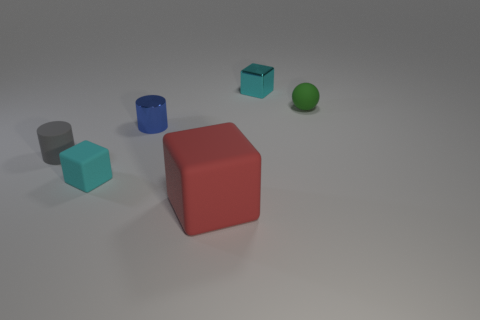Is there any other thing that has the same size as the red matte cube?
Keep it short and to the point. No. Is the shape of the small blue object the same as the big red rubber object?
Your answer should be very brief. No. What is the material of the thing that is the same color as the tiny matte cube?
Keep it short and to the point. Metal. Is the color of the tiny ball the same as the big matte thing?
Give a very brief answer. No. There is a cyan thing that is on the left side of the small cyan thing right of the big red object; how many tiny metallic cubes are on the right side of it?
Ensure brevity in your answer.  1. What shape is the tiny cyan thing that is the same material as the blue cylinder?
Provide a short and direct response. Cube. The tiny cyan block in front of the small metallic object on the left side of the small cyan block that is behind the green rubber ball is made of what material?
Give a very brief answer. Rubber. How many things are either cyan objects that are left of the rubber sphere or green matte balls?
Your response must be concise. 3. How many other things are the same shape as the large red matte thing?
Your answer should be compact. 2. Is the number of cyan blocks that are on the right side of the small green ball greater than the number of tiny cyan shiny things?
Provide a succinct answer. No. 